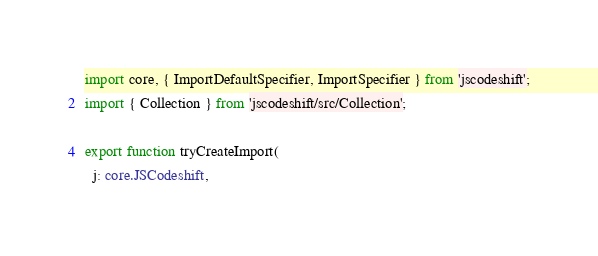<code> <loc_0><loc_0><loc_500><loc_500><_TypeScript_>import core, { ImportDefaultSpecifier, ImportSpecifier } from 'jscodeshift';
import { Collection } from 'jscodeshift/src/Collection';

export function tryCreateImport(
  j: core.JSCodeshift,</code> 